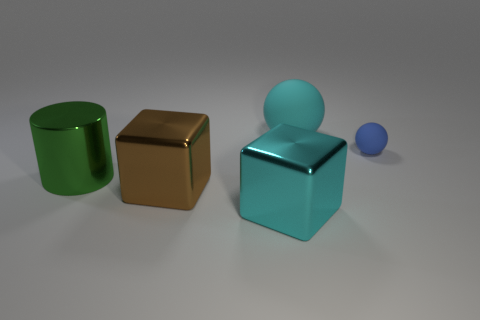Add 1 rubber things. How many objects exist? 6 Subtract all blocks. How many objects are left? 3 Subtract all small yellow metal blocks. Subtract all big cylinders. How many objects are left? 4 Add 1 blue matte objects. How many blue matte objects are left? 2 Add 1 big brown blocks. How many big brown blocks exist? 2 Subtract 0 gray cylinders. How many objects are left? 5 